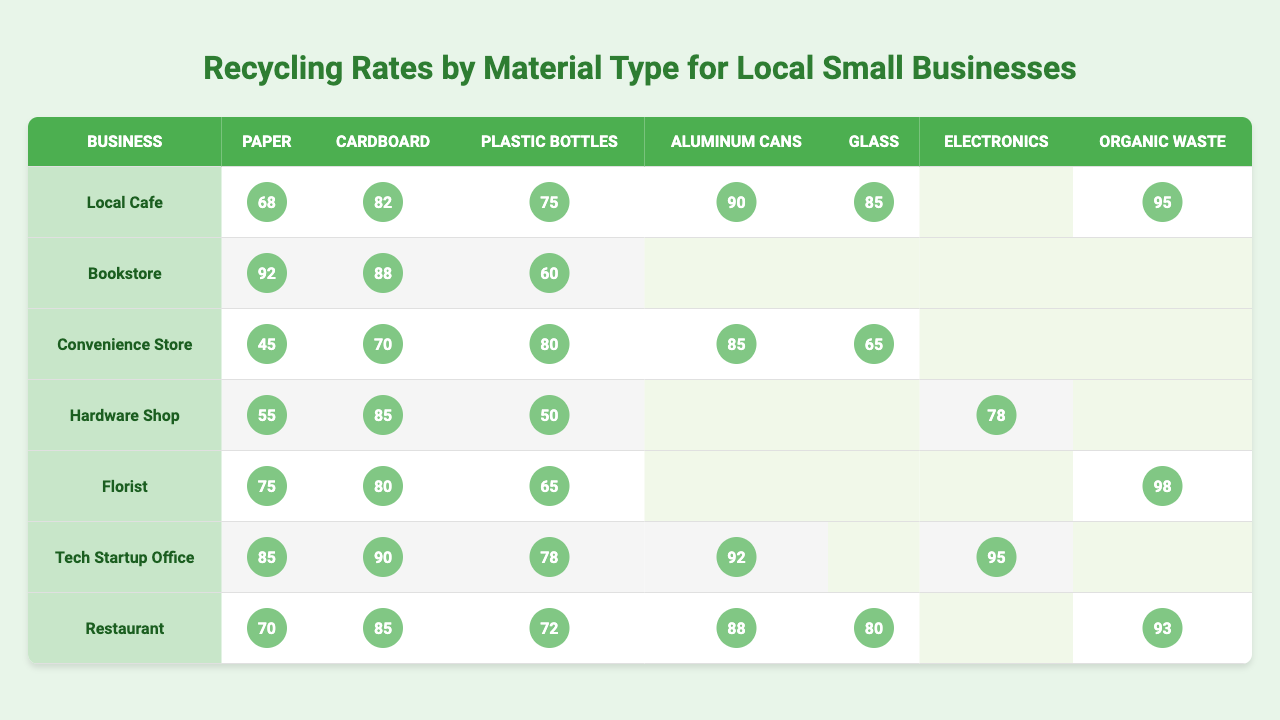What is the recycling rate for aluminum cans from the Tech Startup Office? The table shows the recycling rate for aluminum cans for the Tech Startup Office, which is listed directly under the respective column for aluminum cans. The recycling rate is 92%.
Answer: 92% Which business has the highest recycling rate for paper? By looking at the paper recycling rates for each business, the Bookstore has the highest at 92%.
Answer: Bookstore What is the average recycling rate for organic waste across the businesses listed in the table? The businesses that have a recycling rate for organic waste are the Local Cafe (95%), Florist (98%), and Restaurant (93%). The total is (95 + 98 + 93) = 286, and there are 3 data points. Therefore, the average is 286 / 3 = 95.33%.
Answer: 95.33% Are the recycling rates for cardboard consistently above 80% across all businesses? The recycling rates for cardboard from the businesses are 82% (Local Cafe), 88% (Bookstore), 70% (Convenience Store), 85% (Hardware Shop), 80% (Florist), 90% (Tech Startup Office), and 85% (Restaurant). The Convenience Store has a rate of 70%, which is below 80%. Therefore, it is not consistent above 80%.
Answer: No What is the difference in the recycling rates for plastic bottles between the Local Cafe and the Restaurant? The Local Cafe has a recycling rate for plastic bottles of 75%, and the Restaurant has a rate of 72%. The difference is calculated as 75% - 72% = 3%.
Answer: 3% Which material had the lowest recycling rate for the Convenience Store? The table indicates that the Convenience Store's lowest recycling rate is for paper, which is 45%.
Answer: Paper How many businesses have a recycling rate of at least 85% for aluminum cans? Checking the recycling rates for aluminum cans shows that the Local Cafe (90%), Tech Startup Office (92%), and Restaurant (88%) meet this criterion. Therefore, there are 3 businesses.
Answer: 3 Which business shows a 0% recycling rate for electronics? The Hardware Shop lists a recycling rate for electronics at 78%, but the other businesses listed do not have a rate for electronics. None show 0%, but the Business names that do not list any value are Bookstore, Convenience Store, Florist, Local Cafe, and Restaurant; therefore, the answer is none listed 0% explicitly while no businesses report an official 0%.
Answer: None (no businesses show a 0% rate) What is the overall trend in recycling rates across businesses for cardboard? The recycling rates for cardboard are 82% (Local Cafe), 88% (Bookstore), 70% (Convenience Store), 85% (Hardware Shop), 80% (Florist), 90% (Tech Startup Office), and 85% (Restaurant). Most are above 80%, indicating a generally favorable trend for cardboard recycling, but the Convenience Store shows a dip.
Answer: Generally favorable, with one dip 